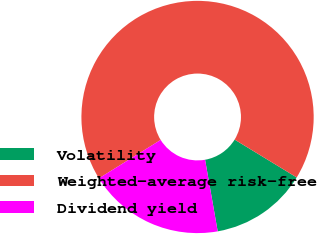<chart> <loc_0><loc_0><loc_500><loc_500><pie_chart><fcel>Volatility<fcel>Weighted-average risk-free<fcel>Dividend yield<nl><fcel>13.51%<fcel>67.57%<fcel>18.92%<nl></chart> 